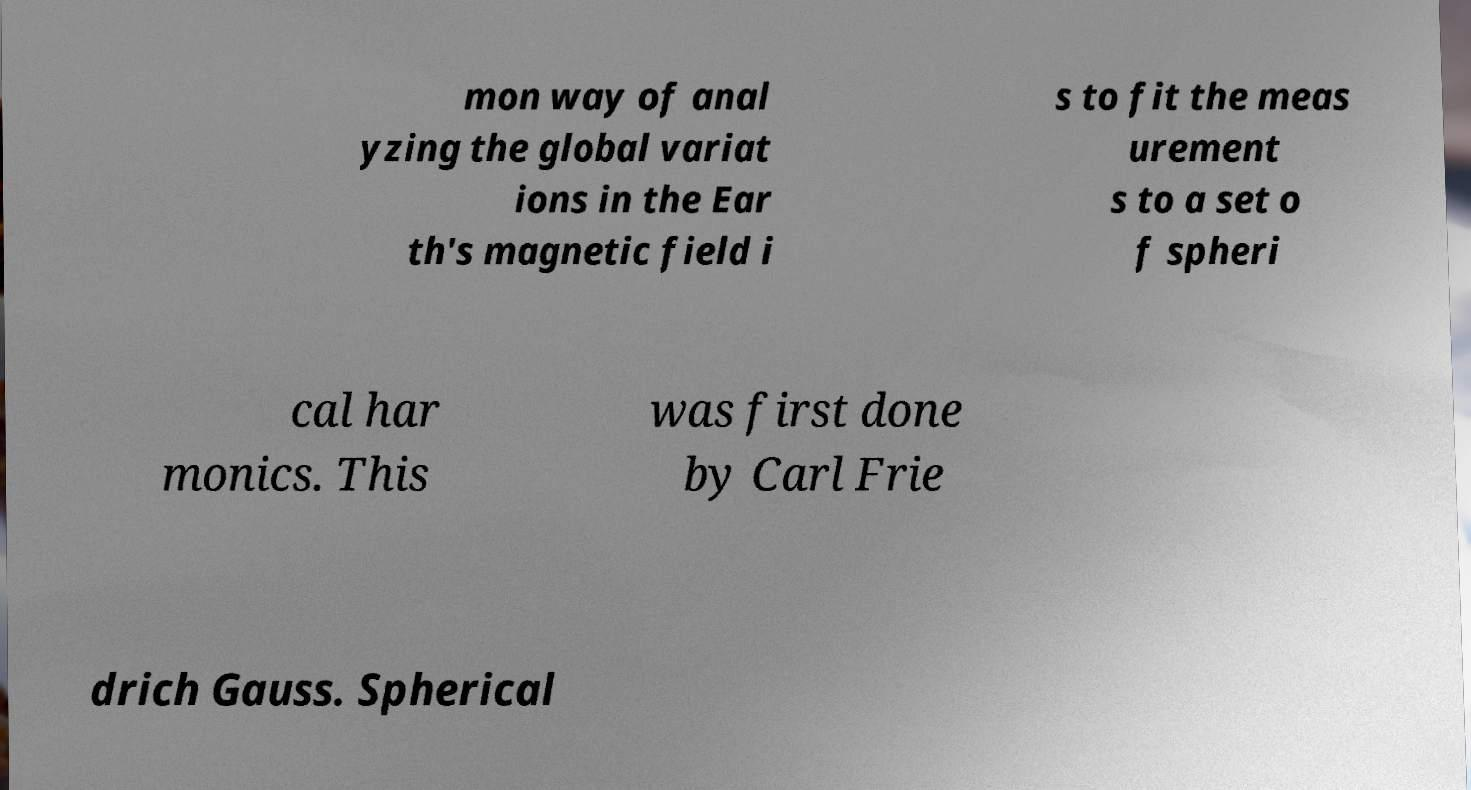Could you assist in decoding the text presented in this image and type it out clearly? mon way of anal yzing the global variat ions in the Ear th's magnetic field i s to fit the meas urement s to a set o f spheri cal har monics. This was first done by Carl Frie drich Gauss. Spherical 